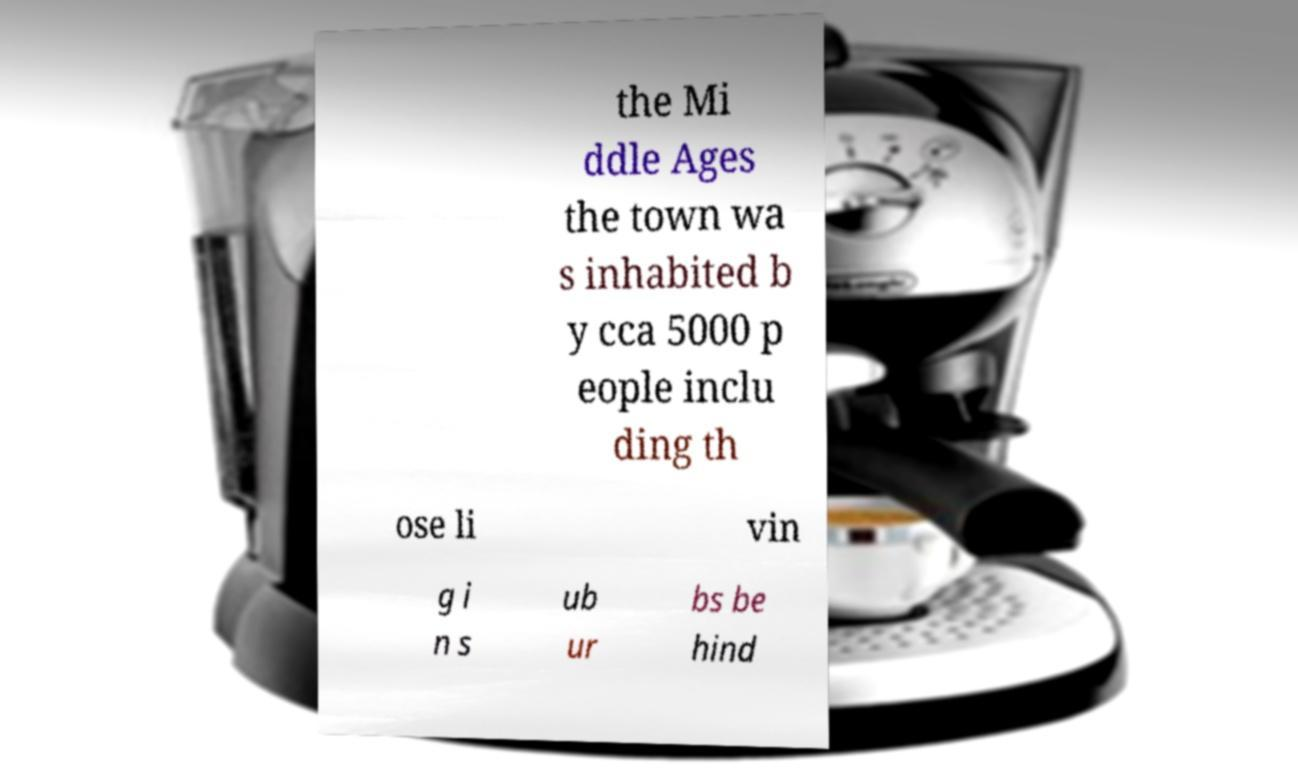For documentation purposes, I need the text within this image transcribed. Could you provide that? the Mi ddle Ages the town wa s inhabited b y cca 5000 p eople inclu ding th ose li vin g i n s ub ur bs be hind 